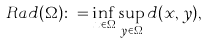Convert formula to latex. <formula><loc_0><loc_0><loc_500><loc_500>R a d ( \Omega ) \colon = \inf _ { x \in \Omega } \sup _ { y \in \Omega } d ( x , y ) ,</formula> 